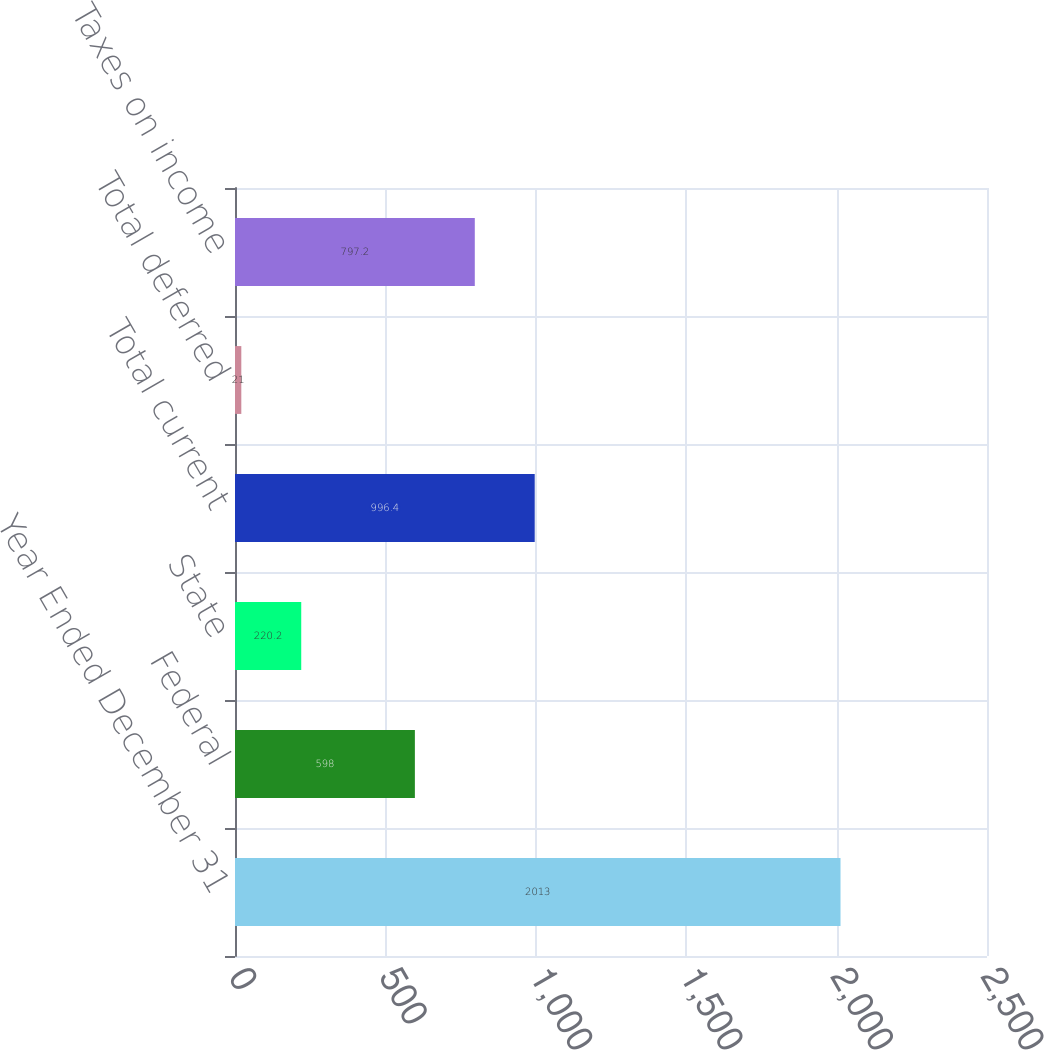<chart> <loc_0><loc_0><loc_500><loc_500><bar_chart><fcel>Year Ended December 31<fcel>Federal<fcel>State<fcel>Total current<fcel>Total deferred<fcel>Taxes on income<nl><fcel>2013<fcel>598<fcel>220.2<fcel>996.4<fcel>21<fcel>797.2<nl></chart> 